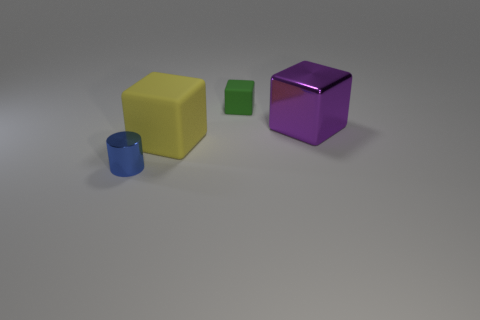Is there a small green object that has the same shape as the blue metallic object?
Provide a short and direct response. No. The other block that is the same size as the metal cube is what color?
Provide a short and direct response. Yellow. There is a rubber object that is left of the small object that is to the right of the tiny cylinder; what color is it?
Provide a short and direct response. Yellow. Is the color of the metallic object right of the big rubber block the same as the tiny metallic object?
Keep it short and to the point. No. The metallic thing that is to the left of the metallic thing to the right of the tiny cube that is to the right of the big yellow matte block is what shape?
Make the answer very short. Cylinder. There is a large thing that is in front of the purple thing; what number of cubes are behind it?
Offer a very short reply. 2. Are the large purple object and the tiny green thing made of the same material?
Make the answer very short. No. There is a rubber block that is on the right side of the big block that is to the left of the small matte block; what number of yellow rubber things are behind it?
Your response must be concise. 0. The cube that is in front of the purple block is what color?
Make the answer very short. Yellow. What shape is the large thing in front of the metallic object behind the tiny cylinder?
Provide a short and direct response. Cube. 